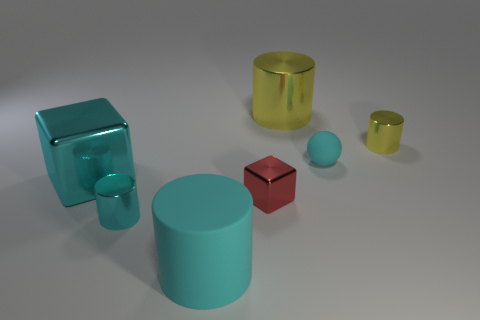Is the red object the same shape as the big rubber object?
Keep it short and to the point. No. Is there a matte sphere that is to the left of the tiny metal cylinder that is in front of the tiny cyan object that is behind the large metallic block?
Offer a terse response. No. What number of other objects are there of the same color as the small ball?
Your response must be concise. 3. Is the size of the cylinder that is on the right side of the matte sphere the same as the yellow cylinder on the left side of the tiny rubber ball?
Offer a terse response. No. Are there an equal number of tiny cyan metal cylinders that are left of the tiny cyan metal object and red cubes behind the tiny cyan sphere?
Your response must be concise. Yes. Are there any other things that have the same material as the tiny red block?
Give a very brief answer. Yes. Is the size of the rubber cylinder the same as the metal cylinder right of the matte sphere?
Your answer should be very brief. No. What material is the tiny cyan thing that is in front of the cube on the left side of the rubber cylinder?
Ensure brevity in your answer.  Metal. Is the number of tiny shiny things on the right side of the big rubber thing the same as the number of big yellow metal cylinders?
Ensure brevity in your answer.  No. There is a shiny object that is behind the small cyan cylinder and in front of the big cyan shiny cube; what size is it?
Offer a very short reply. Small. 